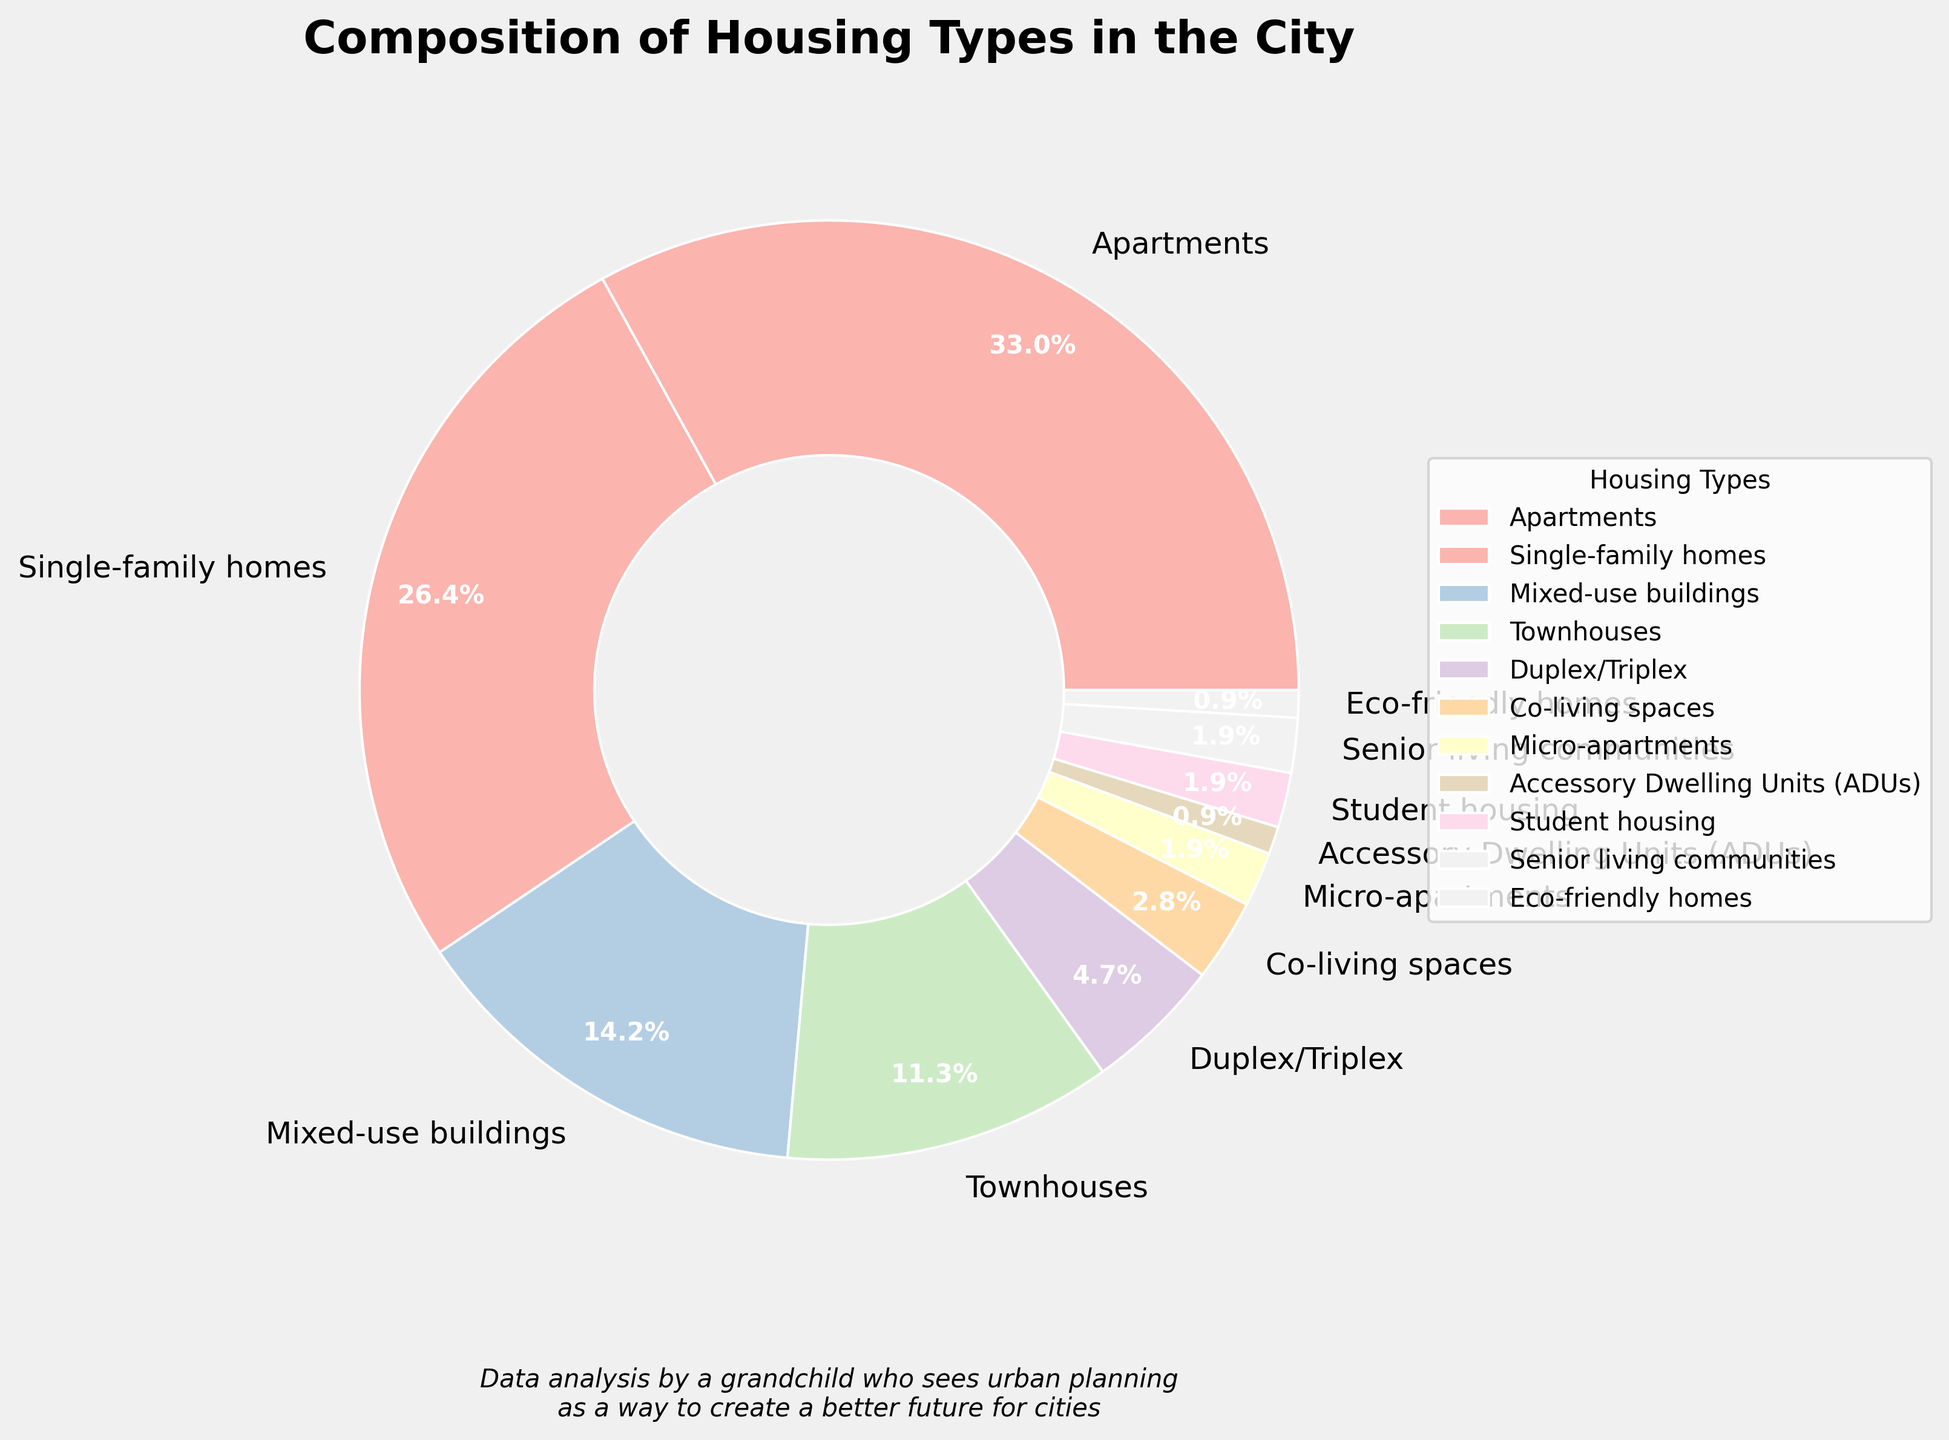What's the largest housing type percentage in the city? The largest percentage of housing type can be identified by looking at the pie chart and finding the sector representing the highest value. Here, apartments have the highest percentage.
Answer: Apartments (35%) Which housing types have an equal population percentage? By examining the pie chart, look for segments with the same percentage. Here, Student housing and Senior living communities both have 2%.
Answer: Student housing, Senior living communities (2%) What is the combined percentage of townhouses, duplex/triplex, and co-living spaces? Add the percentages of townhouses (12%), duplex/triplex (5%), and co-living spaces (3%). So, 12% + 5% + 3% = 20%.
Answer: 20% Which housing type has the smallest share in the city? Identify the smallest sector in the pie chart. It represents ADUs and Eco-friendly homes, each with 1%.
Answer: ADUs, Eco-friendly homes (1%) How do single-family homes compare to mixed-use buildings in terms of percentage? Compare the pie chart sections for single-family homes (28%) and mixed-use buildings (15%). Single-family homes have a higher percentage.
Answer: Single-family homes What percentage of the city's housing is accounted for by apartments and single-family homes together? Add the percentages of apartments (35%) and single-family homes (28%). So, 35% + 28% = 63%.
Answer: 63% Are townhouses more prevalent than duplex/triplex in the city? By looking at the chart, the percentage of townhouses (12%) is greater than that of duplex/triplex (5%).
Answer: Yes What housing types constitute less than 5% each? Identify slices of the pie chart that cover less than 5%. These are duplex/triplex (5%), co-living spaces (3%), micro-apartments (2%), ADUs (1%), student housing (2%), senior living communities (2%), and eco-friendly homes (1%).
Answer: Duplex/Triplex, Co-living spaces, Micro-apartments, ADUs, Student housing, Senior living communities, Eco-friendly homes Which housing type is in the middle rank by percentage? Sort the housing types by percentage and find the middle one. Ordered list: ADUs (1%), eco-friendly homes (1%), micro-apartments (2%), senior living communities (2%), student housing (2%), co-living spaces (3%), duplex/triplex (5%), townhouses (12%), mixed-use buildings (15%), single-family homes (28%), apartments (35%). The middle one is co-living spaces (3%).
Answer: Co-living spaces (3%) 